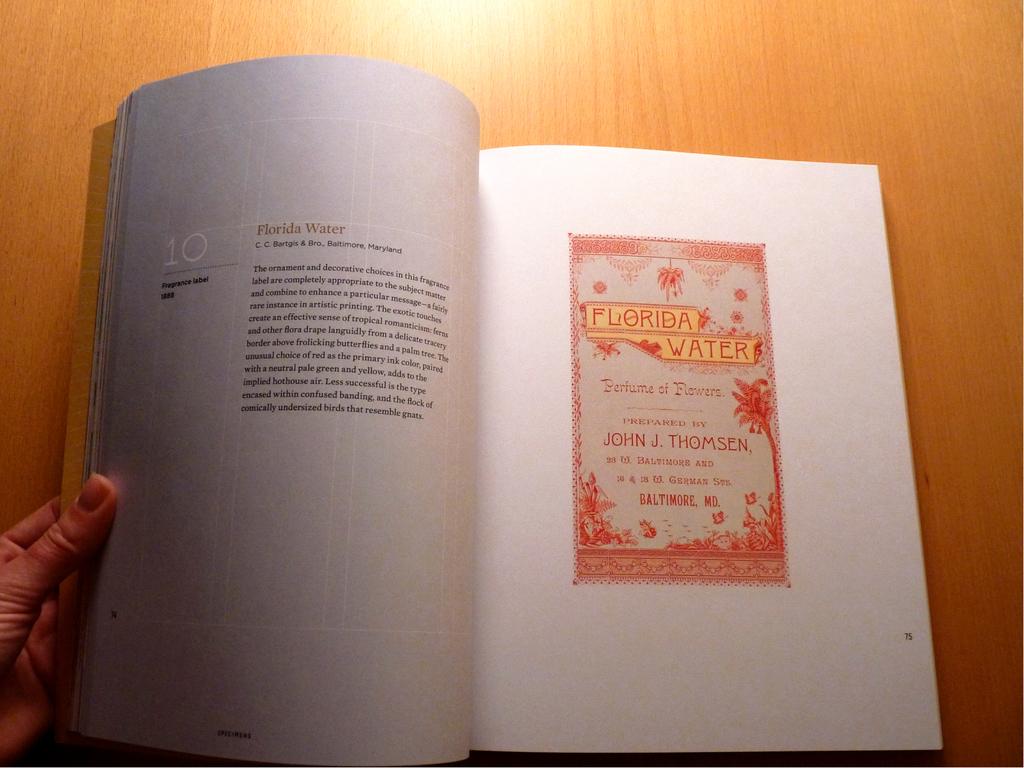Who prepared this?
Provide a succinct answer. John j. thomsen. What is the title of this piece of writing?
Keep it short and to the point. Florida water. 